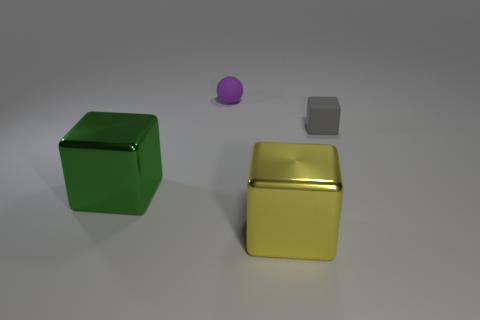What number of yellow metal objects are on the left side of the small matte ball?
Make the answer very short. 0. How many small red cylinders are made of the same material as the yellow block?
Provide a succinct answer. 0. Is the material of the thing that is behind the tiny matte block the same as the tiny gray object?
Your response must be concise. Yes. Are any big blue matte cylinders visible?
Make the answer very short. No. How big is the object that is on the left side of the yellow block and in front of the purple thing?
Give a very brief answer. Large. Is the number of small rubber things left of the gray matte cube greater than the number of purple matte spheres that are on the right side of the large yellow metallic thing?
Offer a terse response. Yes. What is the color of the rubber cube?
Your answer should be compact. Gray. What color is the object that is left of the yellow metal cube and in front of the small matte sphere?
Give a very brief answer. Green. There is a small thing that is in front of the small matte thing behind the tiny gray rubber object right of the purple matte thing; what color is it?
Provide a short and direct response. Gray. What is the color of the other shiny block that is the same size as the yellow shiny block?
Offer a terse response. Green. 